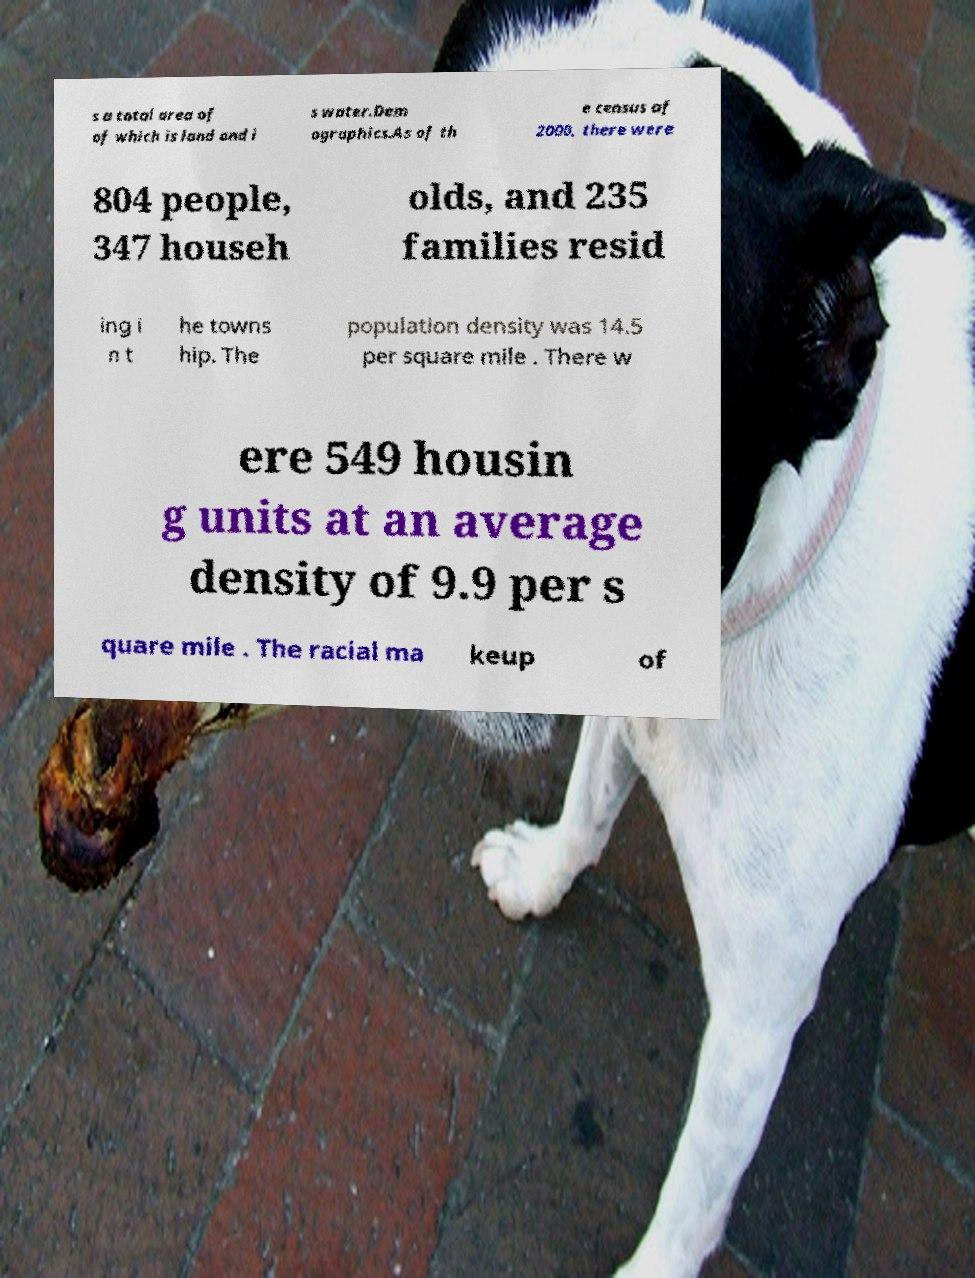Please identify and transcribe the text found in this image. s a total area of of which is land and i s water.Dem ographics.As of th e census of 2000, there were 804 people, 347 househ olds, and 235 families resid ing i n t he towns hip. The population density was 14.5 per square mile . There w ere 549 housin g units at an average density of 9.9 per s quare mile . The racial ma keup of 